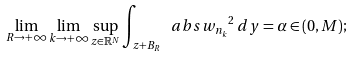Convert formula to latex. <formula><loc_0><loc_0><loc_500><loc_500>\lim _ { R \to + \infty } \lim _ { k \to + \infty } \sup _ { z \in \mathbb { R } ^ { N } } \int _ { z + B _ { R } } \ a b s { w _ { n _ { k } } } ^ { 2 } \, d y = \alpha \in ( 0 , M ) ;</formula> 